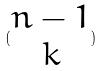<formula> <loc_0><loc_0><loc_500><loc_500>( \begin{matrix} n - 1 \\ k \end{matrix} )</formula> 